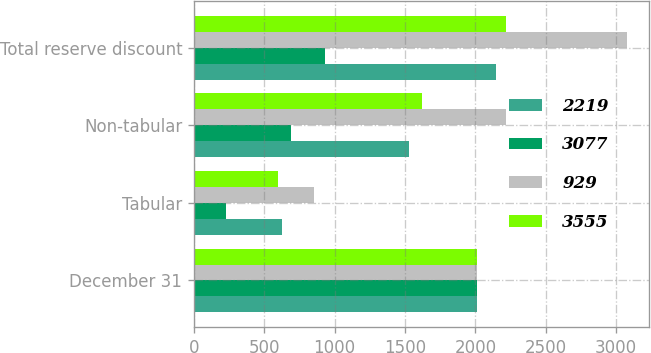Convert chart. <chart><loc_0><loc_0><loc_500><loc_500><stacked_bar_chart><ecel><fcel>December 31<fcel>Tabular<fcel>Non-tabular<fcel>Total reserve discount<nl><fcel>2219<fcel>2014<fcel>623<fcel>1525<fcel>2148<nl><fcel>3077<fcel>2014<fcel>229<fcel>689<fcel>929<nl><fcel>929<fcel>2014<fcel>852<fcel>2214<fcel>3077<nl><fcel>3555<fcel>2013<fcel>597<fcel>1622<fcel>2219<nl></chart> 